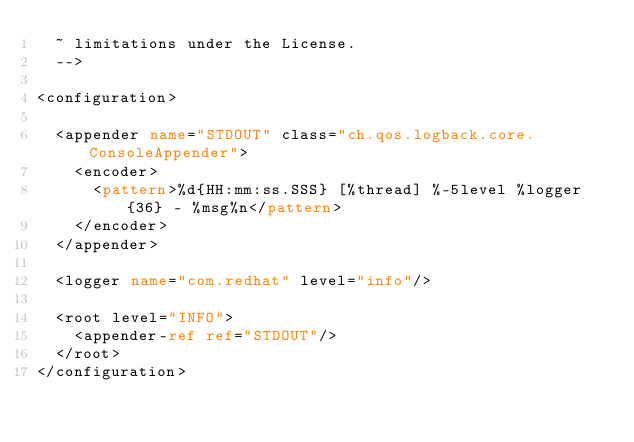<code> <loc_0><loc_0><loc_500><loc_500><_XML_>  ~ limitations under the License.
  -->

<configuration>

  <appender name="STDOUT" class="ch.qos.logback.core.ConsoleAppender">
    <encoder>
      <pattern>%d{HH:mm:ss.SSS} [%thread] %-5level %logger{36} - %msg%n</pattern>
    </encoder>
  </appender>

  <logger name="com.redhat" level="info"/>

  <root level="INFO">
    <appender-ref ref="STDOUT"/>
  </root>
</configuration></code> 